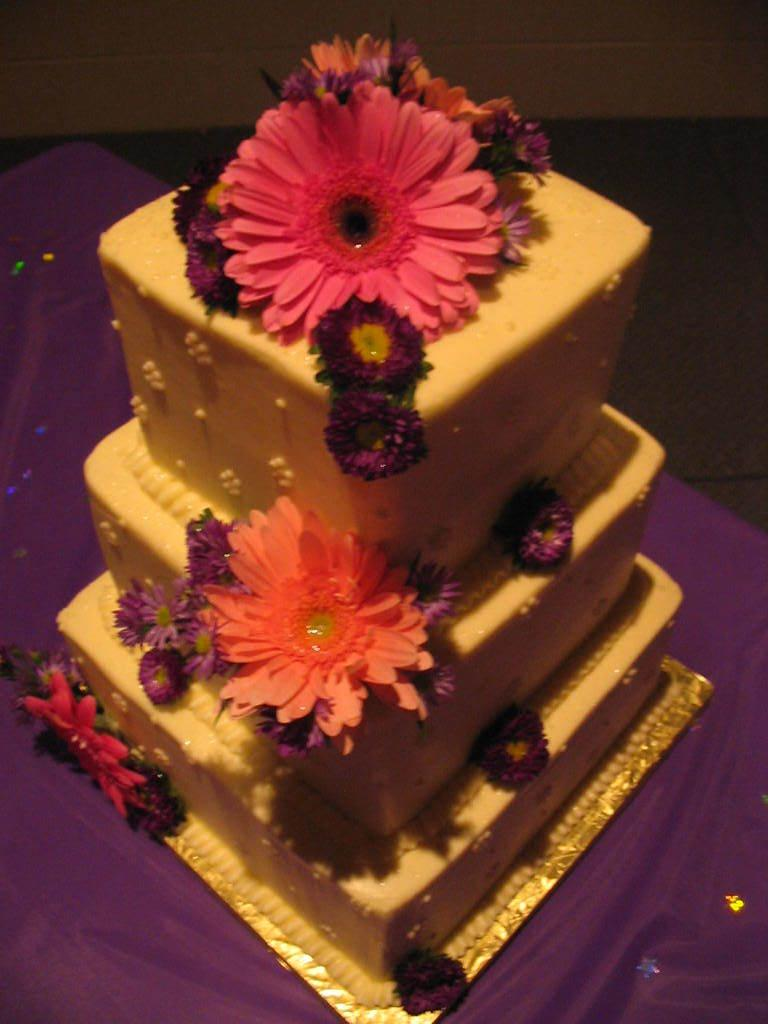What is the main subject of the image? There is a three-tiered cake in the image. Where is the cake located? The cake is placed on a surface. What decorations can be seen on the cake? There are flowers present on the cake. What type of peace symbol can be seen on the cake? There is no peace symbol present on the cake; it features flowers as decorations. What type of quince is used as a topping on the cake? There is no quince present on the cake; it features flowers as decorations. 